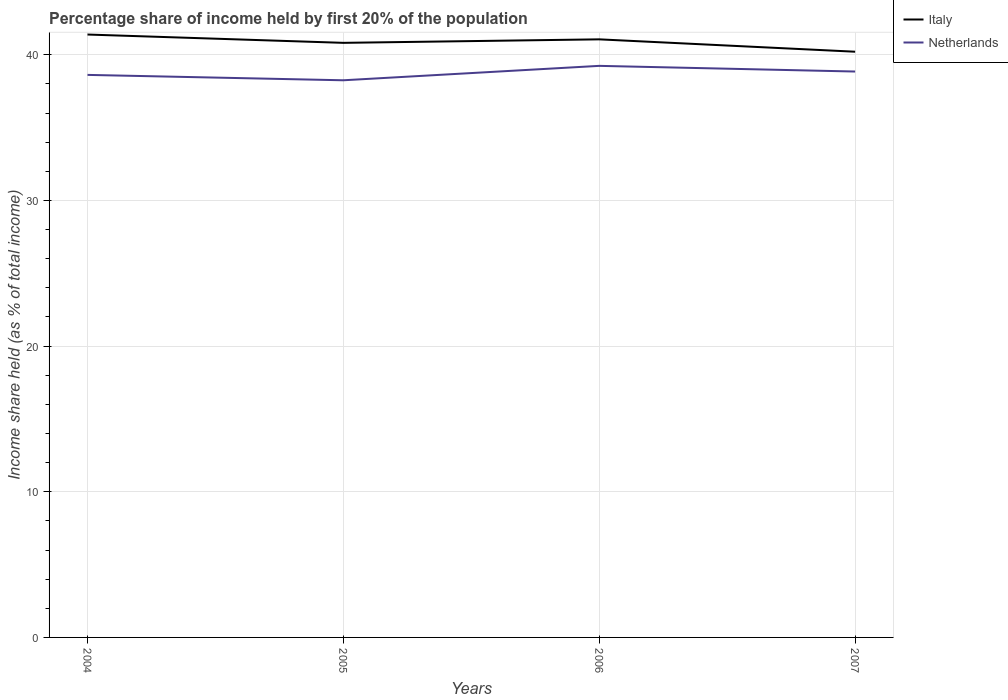Is the number of lines equal to the number of legend labels?
Provide a short and direct response. Yes. Across all years, what is the maximum share of income held by first 20% of the population in Netherlands?
Keep it short and to the point. 38.25. In which year was the share of income held by first 20% of the population in Italy maximum?
Keep it short and to the point. 2007. What is the total share of income held by first 20% of the population in Italy in the graph?
Your response must be concise. 0.85. What is the difference between the highest and the second highest share of income held by first 20% of the population in Netherlands?
Provide a short and direct response. 0.99. How many lines are there?
Make the answer very short. 2. Does the graph contain any zero values?
Provide a succinct answer. No. Where does the legend appear in the graph?
Make the answer very short. Top right. How many legend labels are there?
Ensure brevity in your answer.  2. What is the title of the graph?
Your response must be concise. Percentage share of income held by first 20% of the population. Does "Suriname" appear as one of the legend labels in the graph?
Make the answer very short. No. What is the label or title of the X-axis?
Your response must be concise. Years. What is the label or title of the Y-axis?
Ensure brevity in your answer.  Income share held (as % of total income). What is the Income share held (as % of total income) in Italy in 2004?
Ensure brevity in your answer.  41.39. What is the Income share held (as % of total income) of Netherlands in 2004?
Your answer should be very brief. 38.62. What is the Income share held (as % of total income) of Italy in 2005?
Offer a terse response. 40.82. What is the Income share held (as % of total income) in Netherlands in 2005?
Offer a very short reply. 38.25. What is the Income share held (as % of total income) of Italy in 2006?
Ensure brevity in your answer.  41.06. What is the Income share held (as % of total income) of Netherlands in 2006?
Give a very brief answer. 39.24. What is the Income share held (as % of total income) in Italy in 2007?
Provide a succinct answer. 40.21. What is the Income share held (as % of total income) in Netherlands in 2007?
Your answer should be very brief. 38.85. Across all years, what is the maximum Income share held (as % of total income) of Italy?
Offer a very short reply. 41.39. Across all years, what is the maximum Income share held (as % of total income) of Netherlands?
Provide a succinct answer. 39.24. Across all years, what is the minimum Income share held (as % of total income) of Italy?
Your answer should be compact. 40.21. Across all years, what is the minimum Income share held (as % of total income) in Netherlands?
Your answer should be very brief. 38.25. What is the total Income share held (as % of total income) of Italy in the graph?
Make the answer very short. 163.48. What is the total Income share held (as % of total income) in Netherlands in the graph?
Your answer should be very brief. 154.96. What is the difference between the Income share held (as % of total income) in Italy in 2004 and that in 2005?
Your response must be concise. 0.57. What is the difference between the Income share held (as % of total income) in Netherlands in 2004 and that in 2005?
Keep it short and to the point. 0.37. What is the difference between the Income share held (as % of total income) in Italy in 2004 and that in 2006?
Your answer should be compact. 0.33. What is the difference between the Income share held (as % of total income) of Netherlands in 2004 and that in 2006?
Give a very brief answer. -0.62. What is the difference between the Income share held (as % of total income) of Italy in 2004 and that in 2007?
Keep it short and to the point. 1.18. What is the difference between the Income share held (as % of total income) of Netherlands in 2004 and that in 2007?
Ensure brevity in your answer.  -0.23. What is the difference between the Income share held (as % of total income) in Italy in 2005 and that in 2006?
Keep it short and to the point. -0.24. What is the difference between the Income share held (as % of total income) in Netherlands in 2005 and that in 2006?
Your answer should be compact. -0.99. What is the difference between the Income share held (as % of total income) of Italy in 2005 and that in 2007?
Offer a terse response. 0.61. What is the difference between the Income share held (as % of total income) of Netherlands in 2005 and that in 2007?
Your response must be concise. -0.6. What is the difference between the Income share held (as % of total income) in Italy in 2006 and that in 2007?
Provide a short and direct response. 0.85. What is the difference between the Income share held (as % of total income) in Netherlands in 2006 and that in 2007?
Your answer should be very brief. 0.39. What is the difference between the Income share held (as % of total income) of Italy in 2004 and the Income share held (as % of total income) of Netherlands in 2005?
Make the answer very short. 3.14. What is the difference between the Income share held (as % of total income) of Italy in 2004 and the Income share held (as % of total income) of Netherlands in 2006?
Provide a short and direct response. 2.15. What is the difference between the Income share held (as % of total income) of Italy in 2004 and the Income share held (as % of total income) of Netherlands in 2007?
Keep it short and to the point. 2.54. What is the difference between the Income share held (as % of total income) in Italy in 2005 and the Income share held (as % of total income) in Netherlands in 2006?
Keep it short and to the point. 1.58. What is the difference between the Income share held (as % of total income) of Italy in 2005 and the Income share held (as % of total income) of Netherlands in 2007?
Ensure brevity in your answer.  1.97. What is the difference between the Income share held (as % of total income) in Italy in 2006 and the Income share held (as % of total income) in Netherlands in 2007?
Ensure brevity in your answer.  2.21. What is the average Income share held (as % of total income) in Italy per year?
Keep it short and to the point. 40.87. What is the average Income share held (as % of total income) in Netherlands per year?
Give a very brief answer. 38.74. In the year 2004, what is the difference between the Income share held (as % of total income) of Italy and Income share held (as % of total income) of Netherlands?
Offer a very short reply. 2.77. In the year 2005, what is the difference between the Income share held (as % of total income) in Italy and Income share held (as % of total income) in Netherlands?
Your response must be concise. 2.57. In the year 2006, what is the difference between the Income share held (as % of total income) of Italy and Income share held (as % of total income) of Netherlands?
Give a very brief answer. 1.82. In the year 2007, what is the difference between the Income share held (as % of total income) in Italy and Income share held (as % of total income) in Netherlands?
Give a very brief answer. 1.36. What is the ratio of the Income share held (as % of total income) in Netherlands in 2004 to that in 2005?
Ensure brevity in your answer.  1.01. What is the ratio of the Income share held (as % of total income) in Netherlands in 2004 to that in 2006?
Keep it short and to the point. 0.98. What is the ratio of the Income share held (as % of total income) in Italy in 2004 to that in 2007?
Ensure brevity in your answer.  1.03. What is the ratio of the Income share held (as % of total income) in Netherlands in 2005 to that in 2006?
Make the answer very short. 0.97. What is the ratio of the Income share held (as % of total income) in Italy in 2005 to that in 2007?
Provide a succinct answer. 1.02. What is the ratio of the Income share held (as % of total income) in Netherlands in 2005 to that in 2007?
Provide a short and direct response. 0.98. What is the ratio of the Income share held (as % of total income) of Italy in 2006 to that in 2007?
Make the answer very short. 1.02. What is the difference between the highest and the second highest Income share held (as % of total income) in Italy?
Your response must be concise. 0.33. What is the difference between the highest and the second highest Income share held (as % of total income) in Netherlands?
Your response must be concise. 0.39. What is the difference between the highest and the lowest Income share held (as % of total income) of Italy?
Offer a very short reply. 1.18. 